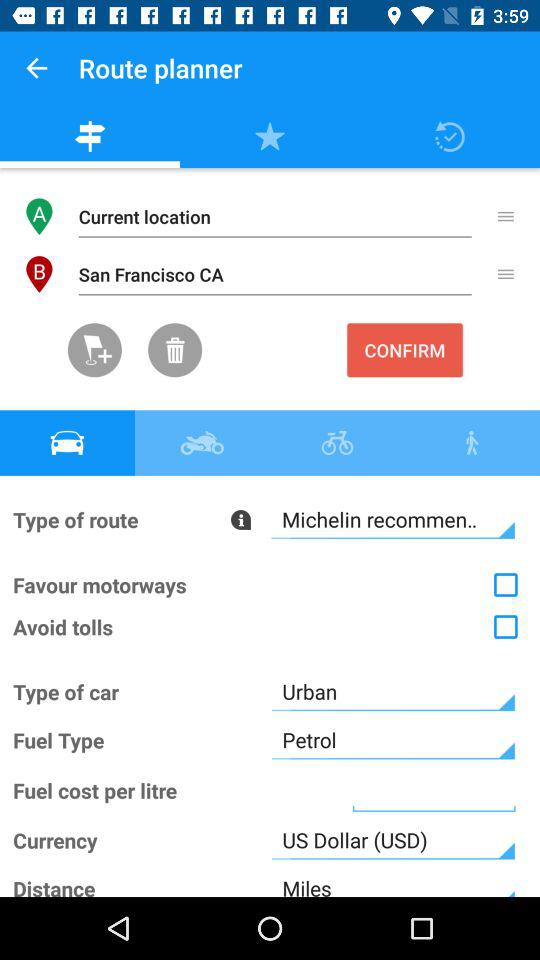What is the selected currency? The selected currency is the US dollar. 